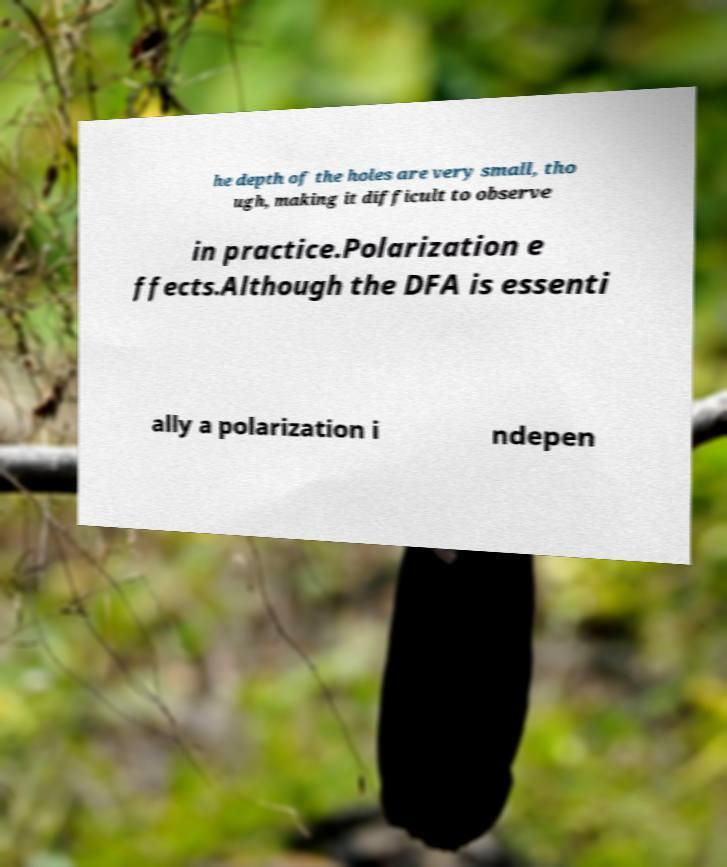Can you read and provide the text displayed in the image?This photo seems to have some interesting text. Can you extract and type it out for me? he depth of the holes are very small, tho ugh, making it difficult to observe in practice.Polarization e ffects.Although the DFA is essenti ally a polarization i ndepen 